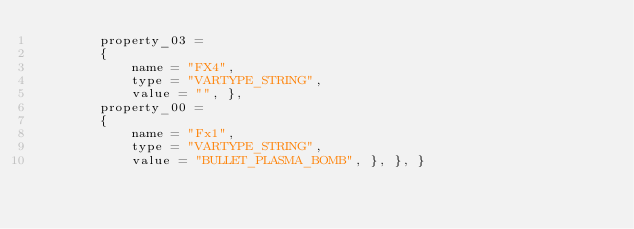<code> <loc_0><loc_0><loc_500><loc_500><_Lua_>        property_03 = 
        { 
            name = "FX4", 
            type = "VARTYPE_STRING", 
            value = "", }, 
        property_00 = 
        { 
            name = "Fx1", 
            type = "VARTYPE_STRING", 
            value = "BULLET_PLASMA_BOMB", }, }, }
</code> 